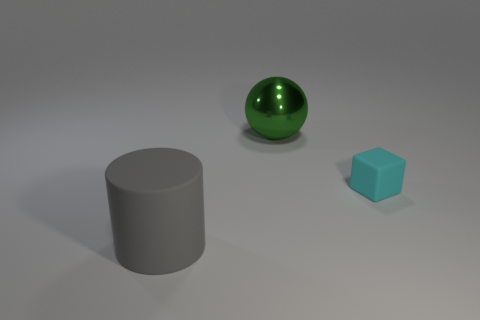Add 3 green shiny balls. How many objects exist? 6 Subtract all cylinders. How many objects are left? 2 Add 3 shiny spheres. How many shiny spheres are left? 4 Add 3 big rubber things. How many big rubber things exist? 4 Subtract 0 brown balls. How many objects are left? 3 Subtract all green cylinders. Subtract all green balls. How many cylinders are left? 1 Subtract all cylinders. Subtract all large objects. How many objects are left? 0 